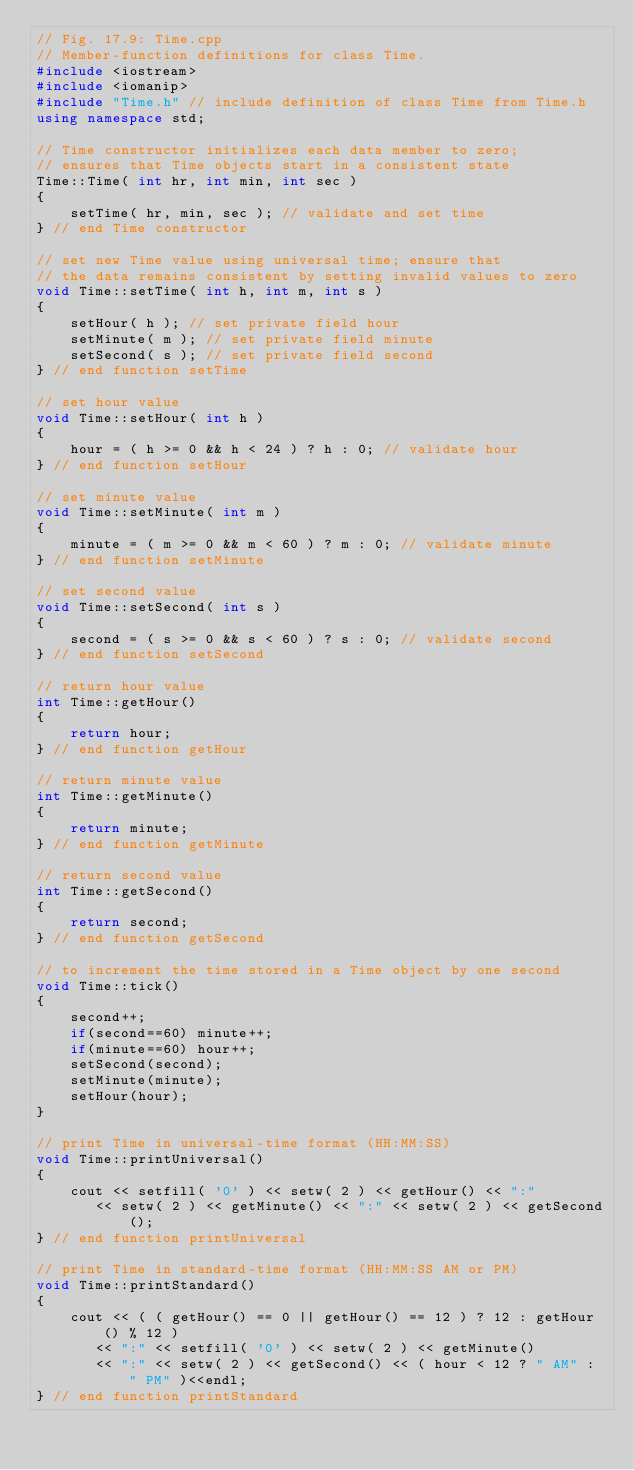<code> <loc_0><loc_0><loc_500><loc_500><_C++_>// Fig. 17.9: Time.cpp
// Member-function definitions for class Time.
#include <iostream>
#include <iomanip>
#include "Time.h" // include definition of class Time from Time.h
using namespace std;

// Time constructor initializes each data member to zero;
// ensures that Time objects start in a consistent state
Time::Time( int hr, int min, int sec )
{
    setTime( hr, min, sec ); // validate and set time
} // end Time constructor

// set new Time value using universal time; ensure that
// the data remains consistent by setting invalid values to zero
void Time::setTime( int h, int m, int s )
{
    setHour( h ); // set private field hour
    setMinute( m ); // set private field minute
    setSecond( s ); // set private field second
} // end function setTime

// set hour value
void Time::setHour( int h )
{
    hour = ( h >= 0 && h < 24 ) ? h : 0; // validate hour
} // end function setHour

// set minute value
void Time::setMinute( int m )
{
    minute = ( m >= 0 && m < 60 ) ? m : 0; // validate minute
} // end function setMinute

// set second value
void Time::setSecond( int s )
{
    second = ( s >= 0 && s < 60 ) ? s : 0; // validate second
} // end function setSecond

// return hour value
int Time::getHour()
{
    return hour;
} // end function getHour

// return minute value
int Time::getMinute()
{
    return minute;
} // end function getMinute

// return second value
int Time::getSecond()
{
    return second;
} // end function getSecond

// to increment the time stored in a Time object by one second
void Time::tick()
{
    second++;
    if(second==60) minute++;
    if(minute==60) hour++;
    setSecond(second);
    setMinute(minute);
    setHour(hour);
}

// print Time in universal-time format (HH:MM:SS)
void Time::printUniversal()
{
    cout << setfill( '0' ) << setw( 2 ) << getHour() << ":"
       << setw( 2 ) << getMinute() << ":" << setw( 2 ) << getSecond();
} // end function printUniversal

// print Time in standard-time format (HH:MM:SS AM or PM)
void Time::printStandard()
{
    cout << ( ( getHour() == 0 || getHour() == 12 ) ? 12 : getHour() % 12 )
       << ":" << setfill( '0' ) << setw( 2 ) << getMinute()
       << ":" << setw( 2 ) << getSecond() << ( hour < 12 ? " AM" : " PM" )<<endl;
} // end function printStandard
</code> 